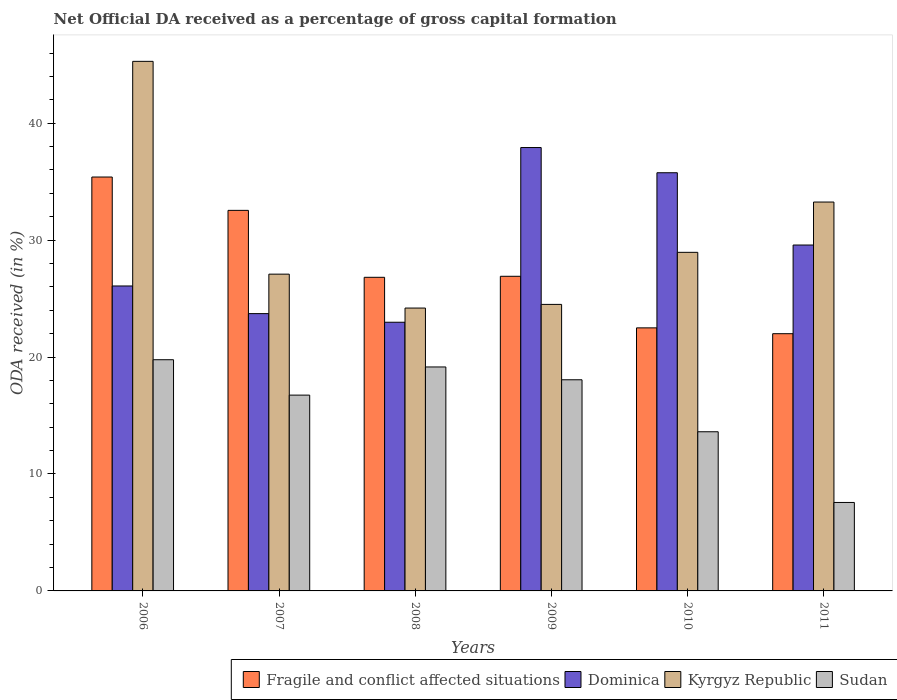How many bars are there on the 5th tick from the right?
Provide a succinct answer. 4. What is the label of the 1st group of bars from the left?
Provide a succinct answer. 2006. In how many cases, is the number of bars for a given year not equal to the number of legend labels?
Offer a very short reply. 0. What is the net ODA received in Sudan in 2006?
Give a very brief answer. 19.77. Across all years, what is the maximum net ODA received in Fragile and conflict affected situations?
Offer a very short reply. 35.4. Across all years, what is the minimum net ODA received in Dominica?
Your answer should be compact. 22.98. In which year was the net ODA received in Kyrgyz Republic minimum?
Make the answer very short. 2008. What is the total net ODA received in Kyrgyz Republic in the graph?
Provide a short and direct response. 183.28. What is the difference between the net ODA received in Fragile and conflict affected situations in 2008 and that in 2009?
Keep it short and to the point. -0.09. What is the difference between the net ODA received in Dominica in 2007 and the net ODA received in Fragile and conflict affected situations in 2009?
Your response must be concise. -3.19. What is the average net ODA received in Dominica per year?
Your answer should be very brief. 29.34. In the year 2007, what is the difference between the net ODA received in Kyrgyz Republic and net ODA received in Fragile and conflict affected situations?
Offer a very short reply. -5.45. In how many years, is the net ODA received in Dominica greater than 44 %?
Ensure brevity in your answer.  0. What is the ratio of the net ODA received in Dominica in 2007 to that in 2008?
Give a very brief answer. 1.03. Is the difference between the net ODA received in Kyrgyz Republic in 2006 and 2007 greater than the difference between the net ODA received in Fragile and conflict affected situations in 2006 and 2007?
Offer a very short reply. Yes. What is the difference between the highest and the second highest net ODA received in Dominica?
Make the answer very short. 2.15. What is the difference between the highest and the lowest net ODA received in Dominica?
Offer a very short reply. 14.94. In how many years, is the net ODA received in Fragile and conflict affected situations greater than the average net ODA received in Fragile and conflict affected situations taken over all years?
Offer a terse response. 2. What does the 2nd bar from the left in 2006 represents?
Make the answer very short. Dominica. What does the 3rd bar from the right in 2007 represents?
Your response must be concise. Dominica. Are all the bars in the graph horizontal?
Make the answer very short. No. How many years are there in the graph?
Offer a very short reply. 6. Does the graph contain any zero values?
Your answer should be compact. No. Where does the legend appear in the graph?
Make the answer very short. Bottom right. How are the legend labels stacked?
Ensure brevity in your answer.  Horizontal. What is the title of the graph?
Offer a very short reply. Net Official DA received as a percentage of gross capital formation. Does "Afghanistan" appear as one of the legend labels in the graph?
Provide a succinct answer. No. What is the label or title of the Y-axis?
Your response must be concise. ODA received (in %). What is the ODA received (in %) of Fragile and conflict affected situations in 2006?
Offer a very short reply. 35.4. What is the ODA received (in %) in Dominica in 2006?
Keep it short and to the point. 26.08. What is the ODA received (in %) in Kyrgyz Republic in 2006?
Ensure brevity in your answer.  45.29. What is the ODA received (in %) of Sudan in 2006?
Your answer should be very brief. 19.77. What is the ODA received (in %) of Fragile and conflict affected situations in 2007?
Provide a short and direct response. 32.54. What is the ODA received (in %) of Dominica in 2007?
Your answer should be very brief. 23.71. What is the ODA received (in %) of Kyrgyz Republic in 2007?
Your answer should be compact. 27.09. What is the ODA received (in %) of Sudan in 2007?
Provide a succinct answer. 16.74. What is the ODA received (in %) in Fragile and conflict affected situations in 2008?
Your response must be concise. 26.82. What is the ODA received (in %) in Dominica in 2008?
Your answer should be compact. 22.98. What is the ODA received (in %) of Kyrgyz Republic in 2008?
Offer a very short reply. 24.19. What is the ODA received (in %) of Sudan in 2008?
Provide a succinct answer. 19.15. What is the ODA received (in %) of Fragile and conflict affected situations in 2009?
Offer a very short reply. 26.91. What is the ODA received (in %) of Dominica in 2009?
Ensure brevity in your answer.  37.92. What is the ODA received (in %) of Kyrgyz Republic in 2009?
Offer a terse response. 24.5. What is the ODA received (in %) of Sudan in 2009?
Your answer should be compact. 18.06. What is the ODA received (in %) in Fragile and conflict affected situations in 2010?
Offer a very short reply. 22.5. What is the ODA received (in %) in Dominica in 2010?
Provide a succinct answer. 35.76. What is the ODA received (in %) in Kyrgyz Republic in 2010?
Offer a very short reply. 28.95. What is the ODA received (in %) of Sudan in 2010?
Give a very brief answer. 13.61. What is the ODA received (in %) of Fragile and conflict affected situations in 2011?
Offer a very short reply. 22. What is the ODA received (in %) of Dominica in 2011?
Your answer should be compact. 29.58. What is the ODA received (in %) of Kyrgyz Republic in 2011?
Give a very brief answer. 33.26. What is the ODA received (in %) in Sudan in 2011?
Provide a short and direct response. 7.57. Across all years, what is the maximum ODA received (in %) of Fragile and conflict affected situations?
Provide a short and direct response. 35.4. Across all years, what is the maximum ODA received (in %) of Dominica?
Provide a short and direct response. 37.92. Across all years, what is the maximum ODA received (in %) in Kyrgyz Republic?
Offer a very short reply. 45.29. Across all years, what is the maximum ODA received (in %) in Sudan?
Your response must be concise. 19.77. Across all years, what is the minimum ODA received (in %) of Fragile and conflict affected situations?
Ensure brevity in your answer.  22. Across all years, what is the minimum ODA received (in %) in Dominica?
Provide a succinct answer. 22.98. Across all years, what is the minimum ODA received (in %) of Kyrgyz Republic?
Give a very brief answer. 24.19. Across all years, what is the minimum ODA received (in %) in Sudan?
Ensure brevity in your answer.  7.57. What is the total ODA received (in %) of Fragile and conflict affected situations in the graph?
Ensure brevity in your answer.  166.15. What is the total ODA received (in %) in Dominica in the graph?
Offer a terse response. 176.02. What is the total ODA received (in %) of Kyrgyz Republic in the graph?
Your answer should be very brief. 183.28. What is the total ODA received (in %) of Sudan in the graph?
Provide a short and direct response. 94.9. What is the difference between the ODA received (in %) in Fragile and conflict affected situations in 2006 and that in 2007?
Offer a very short reply. 2.85. What is the difference between the ODA received (in %) of Dominica in 2006 and that in 2007?
Give a very brief answer. 2.36. What is the difference between the ODA received (in %) of Kyrgyz Republic in 2006 and that in 2007?
Give a very brief answer. 18.2. What is the difference between the ODA received (in %) of Sudan in 2006 and that in 2007?
Your answer should be compact. 3.03. What is the difference between the ODA received (in %) of Fragile and conflict affected situations in 2006 and that in 2008?
Your response must be concise. 8.58. What is the difference between the ODA received (in %) in Dominica in 2006 and that in 2008?
Your response must be concise. 3.1. What is the difference between the ODA received (in %) of Kyrgyz Republic in 2006 and that in 2008?
Offer a very short reply. 21.1. What is the difference between the ODA received (in %) in Sudan in 2006 and that in 2008?
Your response must be concise. 0.62. What is the difference between the ODA received (in %) of Fragile and conflict affected situations in 2006 and that in 2009?
Offer a terse response. 8.49. What is the difference between the ODA received (in %) in Dominica in 2006 and that in 2009?
Your answer should be very brief. -11.84. What is the difference between the ODA received (in %) in Kyrgyz Republic in 2006 and that in 2009?
Your answer should be compact. 20.78. What is the difference between the ODA received (in %) in Sudan in 2006 and that in 2009?
Offer a very short reply. 1.71. What is the difference between the ODA received (in %) in Fragile and conflict affected situations in 2006 and that in 2010?
Your answer should be very brief. 12.9. What is the difference between the ODA received (in %) of Dominica in 2006 and that in 2010?
Offer a terse response. -9.68. What is the difference between the ODA received (in %) in Kyrgyz Republic in 2006 and that in 2010?
Make the answer very short. 16.33. What is the difference between the ODA received (in %) of Sudan in 2006 and that in 2010?
Offer a terse response. 6.16. What is the difference between the ODA received (in %) of Fragile and conflict affected situations in 2006 and that in 2011?
Ensure brevity in your answer.  13.4. What is the difference between the ODA received (in %) in Dominica in 2006 and that in 2011?
Give a very brief answer. -3.5. What is the difference between the ODA received (in %) in Kyrgyz Republic in 2006 and that in 2011?
Offer a very short reply. 12.03. What is the difference between the ODA received (in %) of Sudan in 2006 and that in 2011?
Your answer should be compact. 12.21. What is the difference between the ODA received (in %) of Fragile and conflict affected situations in 2007 and that in 2008?
Offer a very short reply. 5.72. What is the difference between the ODA received (in %) of Dominica in 2007 and that in 2008?
Keep it short and to the point. 0.74. What is the difference between the ODA received (in %) of Kyrgyz Republic in 2007 and that in 2008?
Keep it short and to the point. 2.9. What is the difference between the ODA received (in %) in Sudan in 2007 and that in 2008?
Your answer should be very brief. -2.41. What is the difference between the ODA received (in %) in Fragile and conflict affected situations in 2007 and that in 2009?
Provide a succinct answer. 5.64. What is the difference between the ODA received (in %) in Dominica in 2007 and that in 2009?
Provide a succinct answer. -14.2. What is the difference between the ODA received (in %) in Kyrgyz Republic in 2007 and that in 2009?
Your answer should be compact. 2.59. What is the difference between the ODA received (in %) of Sudan in 2007 and that in 2009?
Ensure brevity in your answer.  -1.31. What is the difference between the ODA received (in %) in Fragile and conflict affected situations in 2007 and that in 2010?
Give a very brief answer. 10.05. What is the difference between the ODA received (in %) in Dominica in 2007 and that in 2010?
Ensure brevity in your answer.  -12.05. What is the difference between the ODA received (in %) of Kyrgyz Republic in 2007 and that in 2010?
Provide a succinct answer. -1.86. What is the difference between the ODA received (in %) in Sudan in 2007 and that in 2010?
Ensure brevity in your answer.  3.13. What is the difference between the ODA received (in %) in Fragile and conflict affected situations in 2007 and that in 2011?
Provide a short and direct response. 10.55. What is the difference between the ODA received (in %) in Dominica in 2007 and that in 2011?
Provide a short and direct response. -5.87. What is the difference between the ODA received (in %) of Kyrgyz Republic in 2007 and that in 2011?
Your answer should be compact. -6.17. What is the difference between the ODA received (in %) of Sudan in 2007 and that in 2011?
Provide a succinct answer. 9.18. What is the difference between the ODA received (in %) of Fragile and conflict affected situations in 2008 and that in 2009?
Your response must be concise. -0.09. What is the difference between the ODA received (in %) in Dominica in 2008 and that in 2009?
Give a very brief answer. -14.94. What is the difference between the ODA received (in %) of Kyrgyz Republic in 2008 and that in 2009?
Your answer should be compact. -0.31. What is the difference between the ODA received (in %) of Sudan in 2008 and that in 2009?
Your response must be concise. 1.1. What is the difference between the ODA received (in %) in Fragile and conflict affected situations in 2008 and that in 2010?
Make the answer very short. 4.32. What is the difference between the ODA received (in %) of Dominica in 2008 and that in 2010?
Provide a short and direct response. -12.79. What is the difference between the ODA received (in %) in Kyrgyz Republic in 2008 and that in 2010?
Provide a succinct answer. -4.76. What is the difference between the ODA received (in %) of Sudan in 2008 and that in 2010?
Your response must be concise. 5.54. What is the difference between the ODA received (in %) in Fragile and conflict affected situations in 2008 and that in 2011?
Provide a succinct answer. 4.82. What is the difference between the ODA received (in %) in Dominica in 2008 and that in 2011?
Ensure brevity in your answer.  -6.6. What is the difference between the ODA received (in %) in Kyrgyz Republic in 2008 and that in 2011?
Offer a very short reply. -9.07. What is the difference between the ODA received (in %) of Sudan in 2008 and that in 2011?
Your response must be concise. 11.59. What is the difference between the ODA received (in %) of Fragile and conflict affected situations in 2009 and that in 2010?
Keep it short and to the point. 4.41. What is the difference between the ODA received (in %) in Dominica in 2009 and that in 2010?
Offer a very short reply. 2.15. What is the difference between the ODA received (in %) in Kyrgyz Republic in 2009 and that in 2010?
Provide a succinct answer. -4.45. What is the difference between the ODA received (in %) in Sudan in 2009 and that in 2010?
Your answer should be compact. 4.45. What is the difference between the ODA received (in %) of Fragile and conflict affected situations in 2009 and that in 2011?
Your answer should be very brief. 4.91. What is the difference between the ODA received (in %) in Dominica in 2009 and that in 2011?
Provide a succinct answer. 8.34. What is the difference between the ODA received (in %) in Kyrgyz Republic in 2009 and that in 2011?
Your answer should be compact. -8.75. What is the difference between the ODA received (in %) of Sudan in 2009 and that in 2011?
Your answer should be very brief. 10.49. What is the difference between the ODA received (in %) of Fragile and conflict affected situations in 2010 and that in 2011?
Your answer should be very brief. 0.5. What is the difference between the ODA received (in %) of Dominica in 2010 and that in 2011?
Offer a very short reply. 6.18. What is the difference between the ODA received (in %) in Kyrgyz Republic in 2010 and that in 2011?
Give a very brief answer. -4.3. What is the difference between the ODA received (in %) in Sudan in 2010 and that in 2011?
Your answer should be compact. 6.05. What is the difference between the ODA received (in %) of Fragile and conflict affected situations in 2006 and the ODA received (in %) of Dominica in 2007?
Offer a very short reply. 11.68. What is the difference between the ODA received (in %) of Fragile and conflict affected situations in 2006 and the ODA received (in %) of Kyrgyz Republic in 2007?
Make the answer very short. 8.31. What is the difference between the ODA received (in %) of Fragile and conflict affected situations in 2006 and the ODA received (in %) of Sudan in 2007?
Make the answer very short. 18.65. What is the difference between the ODA received (in %) of Dominica in 2006 and the ODA received (in %) of Kyrgyz Republic in 2007?
Make the answer very short. -1.01. What is the difference between the ODA received (in %) of Dominica in 2006 and the ODA received (in %) of Sudan in 2007?
Provide a short and direct response. 9.33. What is the difference between the ODA received (in %) in Kyrgyz Republic in 2006 and the ODA received (in %) in Sudan in 2007?
Your answer should be compact. 28.54. What is the difference between the ODA received (in %) in Fragile and conflict affected situations in 2006 and the ODA received (in %) in Dominica in 2008?
Offer a terse response. 12.42. What is the difference between the ODA received (in %) of Fragile and conflict affected situations in 2006 and the ODA received (in %) of Kyrgyz Republic in 2008?
Provide a short and direct response. 11.21. What is the difference between the ODA received (in %) of Fragile and conflict affected situations in 2006 and the ODA received (in %) of Sudan in 2008?
Provide a short and direct response. 16.24. What is the difference between the ODA received (in %) of Dominica in 2006 and the ODA received (in %) of Kyrgyz Republic in 2008?
Your answer should be compact. 1.89. What is the difference between the ODA received (in %) of Dominica in 2006 and the ODA received (in %) of Sudan in 2008?
Keep it short and to the point. 6.93. What is the difference between the ODA received (in %) of Kyrgyz Republic in 2006 and the ODA received (in %) of Sudan in 2008?
Offer a very short reply. 26.13. What is the difference between the ODA received (in %) in Fragile and conflict affected situations in 2006 and the ODA received (in %) in Dominica in 2009?
Your answer should be very brief. -2.52. What is the difference between the ODA received (in %) in Fragile and conflict affected situations in 2006 and the ODA received (in %) in Kyrgyz Republic in 2009?
Provide a short and direct response. 10.89. What is the difference between the ODA received (in %) in Fragile and conflict affected situations in 2006 and the ODA received (in %) in Sudan in 2009?
Your response must be concise. 17.34. What is the difference between the ODA received (in %) of Dominica in 2006 and the ODA received (in %) of Kyrgyz Republic in 2009?
Give a very brief answer. 1.58. What is the difference between the ODA received (in %) in Dominica in 2006 and the ODA received (in %) in Sudan in 2009?
Give a very brief answer. 8.02. What is the difference between the ODA received (in %) of Kyrgyz Republic in 2006 and the ODA received (in %) of Sudan in 2009?
Make the answer very short. 27.23. What is the difference between the ODA received (in %) of Fragile and conflict affected situations in 2006 and the ODA received (in %) of Dominica in 2010?
Keep it short and to the point. -0.37. What is the difference between the ODA received (in %) in Fragile and conflict affected situations in 2006 and the ODA received (in %) in Kyrgyz Republic in 2010?
Give a very brief answer. 6.44. What is the difference between the ODA received (in %) in Fragile and conflict affected situations in 2006 and the ODA received (in %) in Sudan in 2010?
Give a very brief answer. 21.78. What is the difference between the ODA received (in %) in Dominica in 2006 and the ODA received (in %) in Kyrgyz Republic in 2010?
Give a very brief answer. -2.88. What is the difference between the ODA received (in %) of Dominica in 2006 and the ODA received (in %) of Sudan in 2010?
Your answer should be very brief. 12.47. What is the difference between the ODA received (in %) of Kyrgyz Republic in 2006 and the ODA received (in %) of Sudan in 2010?
Offer a very short reply. 31.68. What is the difference between the ODA received (in %) in Fragile and conflict affected situations in 2006 and the ODA received (in %) in Dominica in 2011?
Your answer should be compact. 5.82. What is the difference between the ODA received (in %) in Fragile and conflict affected situations in 2006 and the ODA received (in %) in Kyrgyz Republic in 2011?
Keep it short and to the point. 2.14. What is the difference between the ODA received (in %) in Fragile and conflict affected situations in 2006 and the ODA received (in %) in Sudan in 2011?
Offer a terse response. 27.83. What is the difference between the ODA received (in %) in Dominica in 2006 and the ODA received (in %) in Kyrgyz Republic in 2011?
Offer a very short reply. -7.18. What is the difference between the ODA received (in %) in Dominica in 2006 and the ODA received (in %) in Sudan in 2011?
Your answer should be very brief. 18.51. What is the difference between the ODA received (in %) in Kyrgyz Republic in 2006 and the ODA received (in %) in Sudan in 2011?
Your answer should be compact. 37.72. What is the difference between the ODA received (in %) in Fragile and conflict affected situations in 2007 and the ODA received (in %) in Dominica in 2008?
Give a very brief answer. 9.57. What is the difference between the ODA received (in %) of Fragile and conflict affected situations in 2007 and the ODA received (in %) of Kyrgyz Republic in 2008?
Ensure brevity in your answer.  8.35. What is the difference between the ODA received (in %) of Fragile and conflict affected situations in 2007 and the ODA received (in %) of Sudan in 2008?
Provide a succinct answer. 13.39. What is the difference between the ODA received (in %) in Dominica in 2007 and the ODA received (in %) in Kyrgyz Republic in 2008?
Make the answer very short. -0.48. What is the difference between the ODA received (in %) of Dominica in 2007 and the ODA received (in %) of Sudan in 2008?
Keep it short and to the point. 4.56. What is the difference between the ODA received (in %) in Kyrgyz Republic in 2007 and the ODA received (in %) in Sudan in 2008?
Your answer should be compact. 7.94. What is the difference between the ODA received (in %) in Fragile and conflict affected situations in 2007 and the ODA received (in %) in Dominica in 2009?
Your answer should be compact. -5.37. What is the difference between the ODA received (in %) in Fragile and conflict affected situations in 2007 and the ODA received (in %) in Kyrgyz Republic in 2009?
Provide a succinct answer. 8.04. What is the difference between the ODA received (in %) of Fragile and conflict affected situations in 2007 and the ODA received (in %) of Sudan in 2009?
Keep it short and to the point. 14.49. What is the difference between the ODA received (in %) of Dominica in 2007 and the ODA received (in %) of Kyrgyz Republic in 2009?
Ensure brevity in your answer.  -0.79. What is the difference between the ODA received (in %) of Dominica in 2007 and the ODA received (in %) of Sudan in 2009?
Your answer should be compact. 5.66. What is the difference between the ODA received (in %) of Kyrgyz Republic in 2007 and the ODA received (in %) of Sudan in 2009?
Your response must be concise. 9.03. What is the difference between the ODA received (in %) in Fragile and conflict affected situations in 2007 and the ODA received (in %) in Dominica in 2010?
Provide a short and direct response. -3.22. What is the difference between the ODA received (in %) in Fragile and conflict affected situations in 2007 and the ODA received (in %) in Kyrgyz Republic in 2010?
Give a very brief answer. 3.59. What is the difference between the ODA received (in %) of Fragile and conflict affected situations in 2007 and the ODA received (in %) of Sudan in 2010?
Keep it short and to the point. 18.93. What is the difference between the ODA received (in %) in Dominica in 2007 and the ODA received (in %) in Kyrgyz Republic in 2010?
Your answer should be very brief. -5.24. What is the difference between the ODA received (in %) in Dominica in 2007 and the ODA received (in %) in Sudan in 2010?
Ensure brevity in your answer.  10.1. What is the difference between the ODA received (in %) in Kyrgyz Republic in 2007 and the ODA received (in %) in Sudan in 2010?
Offer a terse response. 13.48. What is the difference between the ODA received (in %) in Fragile and conflict affected situations in 2007 and the ODA received (in %) in Dominica in 2011?
Offer a very short reply. 2.96. What is the difference between the ODA received (in %) in Fragile and conflict affected situations in 2007 and the ODA received (in %) in Kyrgyz Republic in 2011?
Provide a succinct answer. -0.71. What is the difference between the ODA received (in %) in Fragile and conflict affected situations in 2007 and the ODA received (in %) in Sudan in 2011?
Offer a very short reply. 24.98. What is the difference between the ODA received (in %) in Dominica in 2007 and the ODA received (in %) in Kyrgyz Republic in 2011?
Your answer should be very brief. -9.54. What is the difference between the ODA received (in %) in Dominica in 2007 and the ODA received (in %) in Sudan in 2011?
Keep it short and to the point. 16.15. What is the difference between the ODA received (in %) of Kyrgyz Republic in 2007 and the ODA received (in %) of Sudan in 2011?
Your answer should be compact. 19.52. What is the difference between the ODA received (in %) in Fragile and conflict affected situations in 2008 and the ODA received (in %) in Dominica in 2009?
Ensure brevity in your answer.  -11.1. What is the difference between the ODA received (in %) of Fragile and conflict affected situations in 2008 and the ODA received (in %) of Kyrgyz Republic in 2009?
Keep it short and to the point. 2.32. What is the difference between the ODA received (in %) of Fragile and conflict affected situations in 2008 and the ODA received (in %) of Sudan in 2009?
Offer a terse response. 8.76. What is the difference between the ODA received (in %) in Dominica in 2008 and the ODA received (in %) in Kyrgyz Republic in 2009?
Keep it short and to the point. -1.53. What is the difference between the ODA received (in %) of Dominica in 2008 and the ODA received (in %) of Sudan in 2009?
Provide a succinct answer. 4.92. What is the difference between the ODA received (in %) in Kyrgyz Republic in 2008 and the ODA received (in %) in Sudan in 2009?
Provide a succinct answer. 6.13. What is the difference between the ODA received (in %) in Fragile and conflict affected situations in 2008 and the ODA received (in %) in Dominica in 2010?
Your answer should be compact. -8.94. What is the difference between the ODA received (in %) of Fragile and conflict affected situations in 2008 and the ODA received (in %) of Kyrgyz Republic in 2010?
Offer a terse response. -2.14. What is the difference between the ODA received (in %) in Fragile and conflict affected situations in 2008 and the ODA received (in %) in Sudan in 2010?
Ensure brevity in your answer.  13.21. What is the difference between the ODA received (in %) of Dominica in 2008 and the ODA received (in %) of Kyrgyz Republic in 2010?
Your answer should be very brief. -5.98. What is the difference between the ODA received (in %) in Dominica in 2008 and the ODA received (in %) in Sudan in 2010?
Give a very brief answer. 9.37. What is the difference between the ODA received (in %) of Kyrgyz Republic in 2008 and the ODA received (in %) of Sudan in 2010?
Make the answer very short. 10.58. What is the difference between the ODA received (in %) of Fragile and conflict affected situations in 2008 and the ODA received (in %) of Dominica in 2011?
Keep it short and to the point. -2.76. What is the difference between the ODA received (in %) in Fragile and conflict affected situations in 2008 and the ODA received (in %) in Kyrgyz Republic in 2011?
Your response must be concise. -6.44. What is the difference between the ODA received (in %) in Fragile and conflict affected situations in 2008 and the ODA received (in %) in Sudan in 2011?
Provide a succinct answer. 19.25. What is the difference between the ODA received (in %) in Dominica in 2008 and the ODA received (in %) in Kyrgyz Republic in 2011?
Your response must be concise. -10.28. What is the difference between the ODA received (in %) of Dominica in 2008 and the ODA received (in %) of Sudan in 2011?
Your answer should be compact. 15.41. What is the difference between the ODA received (in %) of Kyrgyz Republic in 2008 and the ODA received (in %) of Sudan in 2011?
Your answer should be very brief. 16.63. What is the difference between the ODA received (in %) in Fragile and conflict affected situations in 2009 and the ODA received (in %) in Dominica in 2010?
Your response must be concise. -8.86. What is the difference between the ODA received (in %) in Fragile and conflict affected situations in 2009 and the ODA received (in %) in Kyrgyz Republic in 2010?
Keep it short and to the point. -2.05. What is the difference between the ODA received (in %) of Fragile and conflict affected situations in 2009 and the ODA received (in %) of Sudan in 2010?
Provide a short and direct response. 13.3. What is the difference between the ODA received (in %) in Dominica in 2009 and the ODA received (in %) in Kyrgyz Republic in 2010?
Ensure brevity in your answer.  8.96. What is the difference between the ODA received (in %) in Dominica in 2009 and the ODA received (in %) in Sudan in 2010?
Give a very brief answer. 24.31. What is the difference between the ODA received (in %) in Kyrgyz Republic in 2009 and the ODA received (in %) in Sudan in 2010?
Make the answer very short. 10.89. What is the difference between the ODA received (in %) in Fragile and conflict affected situations in 2009 and the ODA received (in %) in Dominica in 2011?
Ensure brevity in your answer.  -2.67. What is the difference between the ODA received (in %) in Fragile and conflict affected situations in 2009 and the ODA received (in %) in Kyrgyz Republic in 2011?
Offer a terse response. -6.35. What is the difference between the ODA received (in %) of Fragile and conflict affected situations in 2009 and the ODA received (in %) of Sudan in 2011?
Provide a short and direct response. 19.34. What is the difference between the ODA received (in %) in Dominica in 2009 and the ODA received (in %) in Kyrgyz Republic in 2011?
Offer a very short reply. 4.66. What is the difference between the ODA received (in %) in Dominica in 2009 and the ODA received (in %) in Sudan in 2011?
Ensure brevity in your answer.  30.35. What is the difference between the ODA received (in %) in Kyrgyz Republic in 2009 and the ODA received (in %) in Sudan in 2011?
Offer a terse response. 16.94. What is the difference between the ODA received (in %) of Fragile and conflict affected situations in 2010 and the ODA received (in %) of Dominica in 2011?
Provide a succinct answer. -7.08. What is the difference between the ODA received (in %) in Fragile and conflict affected situations in 2010 and the ODA received (in %) in Kyrgyz Republic in 2011?
Your response must be concise. -10.76. What is the difference between the ODA received (in %) of Fragile and conflict affected situations in 2010 and the ODA received (in %) of Sudan in 2011?
Give a very brief answer. 14.93. What is the difference between the ODA received (in %) in Dominica in 2010 and the ODA received (in %) in Kyrgyz Republic in 2011?
Provide a succinct answer. 2.51. What is the difference between the ODA received (in %) of Dominica in 2010 and the ODA received (in %) of Sudan in 2011?
Ensure brevity in your answer.  28.2. What is the difference between the ODA received (in %) in Kyrgyz Republic in 2010 and the ODA received (in %) in Sudan in 2011?
Offer a very short reply. 21.39. What is the average ODA received (in %) of Fragile and conflict affected situations per year?
Ensure brevity in your answer.  27.69. What is the average ODA received (in %) in Dominica per year?
Your response must be concise. 29.34. What is the average ODA received (in %) of Kyrgyz Republic per year?
Provide a succinct answer. 30.55. What is the average ODA received (in %) in Sudan per year?
Keep it short and to the point. 15.82. In the year 2006, what is the difference between the ODA received (in %) of Fragile and conflict affected situations and ODA received (in %) of Dominica?
Provide a short and direct response. 9.32. In the year 2006, what is the difference between the ODA received (in %) in Fragile and conflict affected situations and ODA received (in %) in Kyrgyz Republic?
Give a very brief answer. -9.89. In the year 2006, what is the difference between the ODA received (in %) of Fragile and conflict affected situations and ODA received (in %) of Sudan?
Your response must be concise. 15.62. In the year 2006, what is the difference between the ODA received (in %) of Dominica and ODA received (in %) of Kyrgyz Republic?
Provide a succinct answer. -19.21. In the year 2006, what is the difference between the ODA received (in %) of Dominica and ODA received (in %) of Sudan?
Offer a very short reply. 6.31. In the year 2006, what is the difference between the ODA received (in %) in Kyrgyz Republic and ODA received (in %) in Sudan?
Offer a terse response. 25.52. In the year 2007, what is the difference between the ODA received (in %) of Fragile and conflict affected situations and ODA received (in %) of Dominica?
Provide a short and direct response. 8.83. In the year 2007, what is the difference between the ODA received (in %) in Fragile and conflict affected situations and ODA received (in %) in Kyrgyz Republic?
Offer a terse response. 5.45. In the year 2007, what is the difference between the ODA received (in %) in Fragile and conflict affected situations and ODA received (in %) in Sudan?
Make the answer very short. 15.8. In the year 2007, what is the difference between the ODA received (in %) of Dominica and ODA received (in %) of Kyrgyz Republic?
Your response must be concise. -3.38. In the year 2007, what is the difference between the ODA received (in %) of Dominica and ODA received (in %) of Sudan?
Your answer should be compact. 6.97. In the year 2007, what is the difference between the ODA received (in %) of Kyrgyz Republic and ODA received (in %) of Sudan?
Give a very brief answer. 10.35. In the year 2008, what is the difference between the ODA received (in %) of Fragile and conflict affected situations and ODA received (in %) of Dominica?
Give a very brief answer. 3.84. In the year 2008, what is the difference between the ODA received (in %) in Fragile and conflict affected situations and ODA received (in %) in Kyrgyz Republic?
Your response must be concise. 2.63. In the year 2008, what is the difference between the ODA received (in %) in Fragile and conflict affected situations and ODA received (in %) in Sudan?
Your answer should be very brief. 7.67. In the year 2008, what is the difference between the ODA received (in %) in Dominica and ODA received (in %) in Kyrgyz Republic?
Your answer should be very brief. -1.21. In the year 2008, what is the difference between the ODA received (in %) in Dominica and ODA received (in %) in Sudan?
Your answer should be compact. 3.82. In the year 2008, what is the difference between the ODA received (in %) in Kyrgyz Republic and ODA received (in %) in Sudan?
Give a very brief answer. 5.04. In the year 2009, what is the difference between the ODA received (in %) of Fragile and conflict affected situations and ODA received (in %) of Dominica?
Provide a succinct answer. -11.01. In the year 2009, what is the difference between the ODA received (in %) of Fragile and conflict affected situations and ODA received (in %) of Kyrgyz Republic?
Offer a terse response. 2.4. In the year 2009, what is the difference between the ODA received (in %) of Fragile and conflict affected situations and ODA received (in %) of Sudan?
Offer a very short reply. 8.85. In the year 2009, what is the difference between the ODA received (in %) in Dominica and ODA received (in %) in Kyrgyz Republic?
Keep it short and to the point. 13.41. In the year 2009, what is the difference between the ODA received (in %) in Dominica and ODA received (in %) in Sudan?
Provide a succinct answer. 19.86. In the year 2009, what is the difference between the ODA received (in %) in Kyrgyz Republic and ODA received (in %) in Sudan?
Give a very brief answer. 6.45. In the year 2010, what is the difference between the ODA received (in %) of Fragile and conflict affected situations and ODA received (in %) of Dominica?
Provide a succinct answer. -13.27. In the year 2010, what is the difference between the ODA received (in %) of Fragile and conflict affected situations and ODA received (in %) of Kyrgyz Republic?
Your answer should be very brief. -6.46. In the year 2010, what is the difference between the ODA received (in %) of Fragile and conflict affected situations and ODA received (in %) of Sudan?
Provide a short and direct response. 8.88. In the year 2010, what is the difference between the ODA received (in %) of Dominica and ODA received (in %) of Kyrgyz Republic?
Give a very brief answer. 6.81. In the year 2010, what is the difference between the ODA received (in %) in Dominica and ODA received (in %) in Sudan?
Your answer should be compact. 22.15. In the year 2010, what is the difference between the ODA received (in %) in Kyrgyz Republic and ODA received (in %) in Sudan?
Offer a very short reply. 15.34. In the year 2011, what is the difference between the ODA received (in %) of Fragile and conflict affected situations and ODA received (in %) of Dominica?
Give a very brief answer. -7.58. In the year 2011, what is the difference between the ODA received (in %) in Fragile and conflict affected situations and ODA received (in %) in Kyrgyz Republic?
Your answer should be compact. -11.26. In the year 2011, what is the difference between the ODA received (in %) in Fragile and conflict affected situations and ODA received (in %) in Sudan?
Offer a terse response. 14.43. In the year 2011, what is the difference between the ODA received (in %) of Dominica and ODA received (in %) of Kyrgyz Republic?
Your response must be concise. -3.68. In the year 2011, what is the difference between the ODA received (in %) in Dominica and ODA received (in %) in Sudan?
Keep it short and to the point. 22.01. In the year 2011, what is the difference between the ODA received (in %) in Kyrgyz Republic and ODA received (in %) in Sudan?
Keep it short and to the point. 25.69. What is the ratio of the ODA received (in %) in Fragile and conflict affected situations in 2006 to that in 2007?
Your response must be concise. 1.09. What is the ratio of the ODA received (in %) of Dominica in 2006 to that in 2007?
Give a very brief answer. 1.1. What is the ratio of the ODA received (in %) of Kyrgyz Republic in 2006 to that in 2007?
Make the answer very short. 1.67. What is the ratio of the ODA received (in %) in Sudan in 2006 to that in 2007?
Your answer should be very brief. 1.18. What is the ratio of the ODA received (in %) in Fragile and conflict affected situations in 2006 to that in 2008?
Offer a terse response. 1.32. What is the ratio of the ODA received (in %) in Dominica in 2006 to that in 2008?
Keep it short and to the point. 1.14. What is the ratio of the ODA received (in %) of Kyrgyz Republic in 2006 to that in 2008?
Make the answer very short. 1.87. What is the ratio of the ODA received (in %) of Sudan in 2006 to that in 2008?
Ensure brevity in your answer.  1.03. What is the ratio of the ODA received (in %) in Fragile and conflict affected situations in 2006 to that in 2009?
Offer a very short reply. 1.32. What is the ratio of the ODA received (in %) in Dominica in 2006 to that in 2009?
Provide a succinct answer. 0.69. What is the ratio of the ODA received (in %) of Kyrgyz Republic in 2006 to that in 2009?
Keep it short and to the point. 1.85. What is the ratio of the ODA received (in %) of Sudan in 2006 to that in 2009?
Your answer should be very brief. 1.09. What is the ratio of the ODA received (in %) in Fragile and conflict affected situations in 2006 to that in 2010?
Keep it short and to the point. 1.57. What is the ratio of the ODA received (in %) of Dominica in 2006 to that in 2010?
Give a very brief answer. 0.73. What is the ratio of the ODA received (in %) of Kyrgyz Republic in 2006 to that in 2010?
Your answer should be very brief. 1.56. What is the ratio of the ODA received (in %) in Sudan in 2006 to that in 2010?
Your answer should be very brief. 1.45. What is the ratio of the ODA received (in %) in Fragile and conflict affected situations in 2006 to that in 2011?
Give a very brief answer. 1.61. What is the ratio of the ODA received (in %) of Dominica in 2006 to that in 2011?
Offer a terse response. 0.88. What is the ratio of the ODA received (in %) in Kyrgyz Republic in 2006 to that in 2011?
Keep it short and to the point. 1.36. What is the ratio of the ODA received (in %) in Sudan in 2006 to that in 2011?
Offer a very short reply. 2.61. What is the ratio of the ODA received (in %) of Fragile and conflict affected situations in 2007 to that in 2008?
Offer a terse response. 1.21. What is the ratio of the ODA received (in %) of Dominica in 2007 to that in 2008?
Provide a short and direct response. 1.03. What is the ratio of the ODA received (in %) in Kyrgyz Republic in 2007 to that in 2008?
Your answer should be very brief. 1.12. What is the ratio of the ODA received (in %) in Sudan in 2007 to that in 2008?
Give a very brief answer. 0.87. What is the ratio of the ODA received (in %) of Fragile and conflict affected situations in 2007 to that in 2009?
Offer a very short reply. 1.21. What is the ratio of the ODA received (in %) in Dominica in 2007 to that in 2009?
Make the answer very short. 0.63. What is the ratio of the ODA received (in %) in Kyrgyz Republic in 2007 to that in 2009?
Make the answer very short. 1.11. What is the ratio of the ODA received (in %) in Sudan in 2007 to that in 2009?
Offer a very short reply. 0.93. What is the ratio of the ODA received (in %) of Fragile and conflict affected situations in 2007 to that in 2010?
Ensure brevity in your answer.  1.45. What is the ratio of the ODA received (in %) of Dominica in 2007 to that in 2010?
Your response must be concise. 0.66. What is the ratio of the ODA received (in %) of Kyrgyz Republic in 2007 to that in 2010?
Your answer should be compact. 0.94. What is the ratio of the ODA received (in %) in Sudan in 2007 to that in 2010?
Ensure brevity in your answer.  1.23. What is the ratio of the ODA received (in %) in Fragile and conflict affected situations in 2007 to that in 2011?
Your answer should be compact. 1.48. What is the ratio of the ODA received (in %) of Dominica in 2007 to that in 2011?
Offer a very short reply. 0.8. What is the ratio of the ODA received (in %) of Kyrgyz Republic in 2007 to that in 2011?
Provide a succinct answer. 0.81. What is the ratio of the ODA received (in %) of Sudan in 2007 to that in 2011?
Offer a terse response. 2.21. What is the ratio of the ODA received (in %) of Dominica in 2008 to that in 2009?
Keep it short and to the point. 0.61. What is the ratio of the ODA received (in %) of Kyrgyz Republic in 2008 to that in 2009?
Keep it short and to the point. 0.99. What is the ratio of the ODA received (in %) in Sudan in 2008 to that in 2009?
Keep it short and to the point. 1.06. What is the ratio of the ODA received (in %) of Fragile and conflict affected situations in 2008 to that in 2010?
Ensure brevity in your answer.  1.19. What is the ratio of the ODA received (in %) in Dominica in 2008 to that in 2010?
Your answer should be very brief. 0.64. What is the ratio of the ODA received (in %) of Kyrgyz Republic in 2008 to that in 2010?
Give a very brief answer. 0.84. What is the ratio of the ODA received (in %) of Sudan in 2008 to that in 2010?
Your answer should be compact. 1.41. What is the ratio of the ODA received (in %) of Fragile and conflict affected situations in 2008 to that in 2011?
Ensure brevity in your answer.  1.22. What is the ratio of the ODA received (in %) in Dominica in 2008 to that in 2011?
Offer a terse response. 0.78. What is the ratio of the ODA received (in %) in Kyrgyz Republic in 2008 to that in 2011?
Make the answer very short. 0.73. What is the ratio of the ODA received (in %) of Sudan in 2008 to that in 2011?
Make the answer very short. 2.53. What is the ratio of the ODA received (in %) in Fragile and conflict affected situations in 2009 to that in 2010?
Ensure brevity in your answer.  1.2. What is the ratio of the ODA received (in %) in Dominica in 2009 to that in 2010?
Offer a very short reply. 1.06. What is the ratio of the ODA received (in %) in Kyrgyz Republic in 2009 to that in 2010?
Your response must be concise. 0.85. What is the ratio of the ODA received (in %) of Sudan in 2009 to that in 2010?
Your answer should be compact. 1.33. What is the ratio of the ODA received (in %) of Fragile and conflict affected situations in 2009 to that in 2011?
Provide a succinct answer. 1.22. What is the ratio of the ODA received (in %) of Dominica in 2009 to that in 2011?
Your answer should be very brief. 1.28. What is the ratio of the ODA received (in %) of Kyrgyz Republic in 2009 to that in 2011?
Offer a terse response. 0.74. What is the ratio of the ODA received (in %) of Sudan in 2009 to that in 2011?
Offer a very short reply. 2.39. What is the ratio of the ODA received (in %) in Fragile and conflict affected situations in 2010 to that in 2011?
Your answer should be compact. 1.02. What is the ratio of the ODA received (in %) of Dominica in 2010 to that in 2011?
Ensure brevity in your answer.  1.21. What is the ratio of the ODA received (in %) in Kyrgyz Republic in 2010 to that in 2011?
Provide a succinct answer. 0.87. What is the ratio of the ODA received (in %) in Sudan in 2010 to that in 2011?
Your response must be concise. 1.8. What is the difference between the highest and the second highest ODA received (in %) of Fragile and conflict affected situations?
Offer a terse response. 2.85. What is the difference between the highest and the second highest ODA received (in %) in Dominica?
Ensure brevity in your answer.  2.15. What is the difference between the highest and the second highest ODA received (in %) of Kyrgyz Republic?
Offer a terse response. 12.03. What is the difference between the highest and the second highest ODA received (in %) of Sudan?
Your answer should be compact. 0.62. What is the difference between the highest and the lowest ODA received (in %) of Fragile and conflict affected situations?
Your answer should be compact. 13.4. What is the difference between the highest and the lowest ODA received (in %) in Dominica?
Make the answer very short. 14.94. What is the difference between the highest and the lowest ODA received (in %) of Kyrgyz Republic?
Your answer should be very brief. 21.1. What is the difference between the highest and the lowest ODA received (in %) in Sudan?
Ensure brevity in your answer.  12.21. 